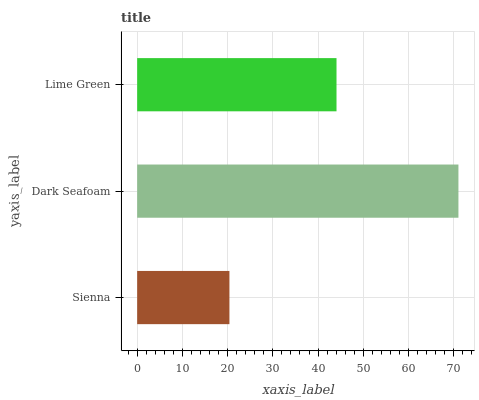Is Sienna the minimum?
Answer yes or no. Yes. Is Dark Seafoam the maximum?
Answer yes or no. Yes. Is Lime Green the minimum?
Answer yes or no. No. Is Lime Green the maximum?
Answer yes or no. No. Is Dark Seafoam greater than Lime Green?
Answer yes or no. Yes. Is Lime Green less than Dark Seafoam?
Answer yes or no. Yes. Is Lime Green greater than Dark Seafoam?
Answer yes or no. No. Is Dark Seafoam less than Lime Green?
Answer yes or no. No. Is Lime Green the high median?
Answer yes or no. Yes. Is Lime Green the low median?
Answer yes or no. Yes. Is Dark Seafoam the high median?
Answer yes or no. No. Is Dark Seafoam the low median?
Answer yes or no. No. 